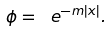Convert formula to latex. <formula><loc_0><loc_0><loc_500><loc_500>\phi = \ e ^ { - m | x | } .</formula> 